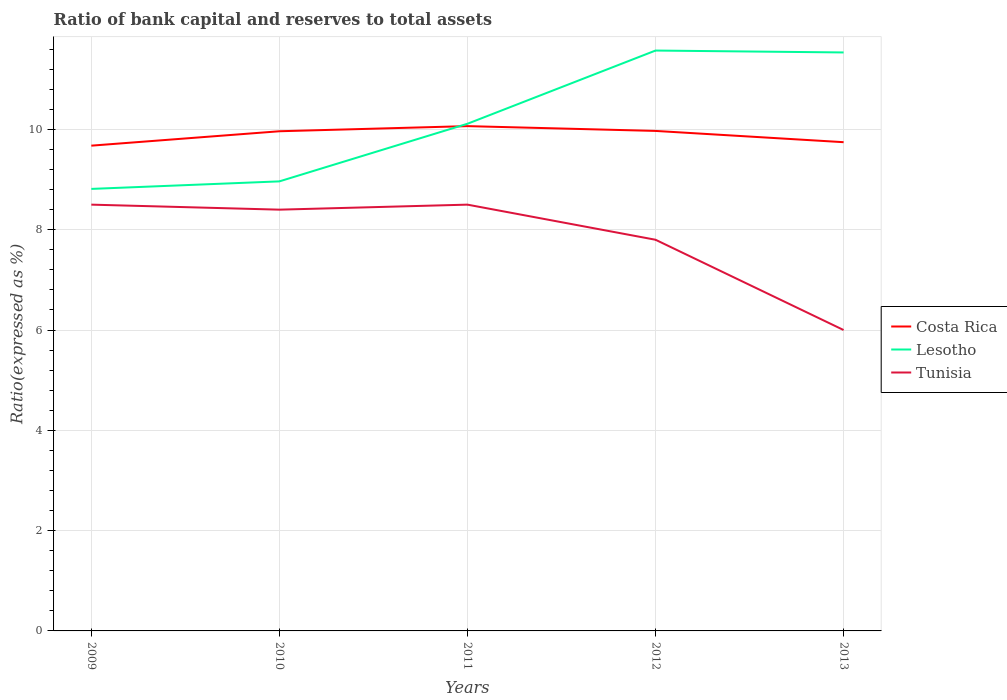How many different coloured lines are there?
Your answer should be compact. 3. Does the line corresponding to Tunisia intersect with the line corresponding to Lesotho?
Offer a terse response. No. What is the total ratio of bank capital and reserves to total assets in Costa Rica in the graph?
Give a very brief answer. -0.07. What is the difference between the highest and the second highest ratio of bank capital and reserves to total assets in Costa Rica?
Ensure brevity in your answer.  0.39. How many lines are there?
Provide a succinct answer. 3. How many years are there in the graph?
Ensure brevity in your answer.  5. Does the graph contain any zero values?
Your answer should be very brief. No. What is the title of the graph?
Offer a very short reply. Ratio of bank capital and reserves to total assets. Does "New Zealand" appear as one of the legend labels in the graph?
Your response must be concise. No. What is the label or title of the Y-axis?
Ensure brevity in your answer.  Ratio(expressed as %). What is the Ratio(expressed as %) in Costa Rica in 2009?
Your answer should be very brief. 9.68. What is the Ratio(expressed as %) in Lesotho in 2009?
Your answer should be very brief. 8.81. What is the Ratio(expressed as %) in Tunisia in 2009?
Your answer should be compact. 8.5. What is the Ratio(expressed as %) of Costa Rica in 2010?
Ensure brevity in your answer.  9.96. What is the Ratio(expressed as %) of Lesotho in 2010?
Offer a very short reply. 8.96. What is the Ratio(expressed as %) in Costa Rica in 2011?
Ensure brevity in your answer.  10.07. What is the Ratio(expressed as %) in Lesotho in 2011?
Ensure brevity in your answer.  10.11. What is the Ratio(expressed as %) of Costa Rica in 2012?
Keep it short and to the point. 9.97. What is the Ratio(expressed as %) in Lesotho in 2012?
Offer a very short reply. 11.57. What is the Ratio(expressed as %) of Costa Rica in 2013?
Offer a terse response. 9.75. What is the Ratio(expressed as %) of Lesotho in 2013?
Make the answer very short. 11.53. What is the Ratio(expressed as %) of Tunisia in 2013?
Provide a short and direct response. 6. Across all years, what is the maximum Ratio(expressed as %) of Costa Rica?
Offer a very short reply. 10.07. Across all years, what is the maximum Ratio(expressed as %) of Lesotho?
Offer a very short reply. 11.57. Across all years, what is the minimum Ratio(expressed as %) of Costa Rica?
Offer a very short reply. 9.68. Across all years, what is the minimum Ratio(expressed as %) of Lesotho?
Make the answer very short. 8.81. Across all years, what is the minimum Ratio(expressed as %) in Tunisia?
Provide a short and direct response. 6. What is the total Ratio(expressed as %) of Costa Rica in the graph?
Your answer should be compact. 49.42. What is the total Ratio(expressed as %) of Lesotho in the graph?
Keep it short and to the point. 51. What is the total Ratio(expressed as %) of Tunisia in the graph?
Make the answer very short. 39.2. What is the difference between the Ratio(expressed as %) of Costa Rica in 2009 and that in 2010?
Offer a terse response. -0.29. What is the difference between the Ratio(expressed as %) in Lesotho in 2009 and that in 2010?
Make the answer very short. -0.15. What is the difference between the Ratio(expressed as %) in Costa Rica in 2009 and that in 2011?
Offer a very short reply. -0.39. What is the difference between the Ratio(expressed as %) of Lesotho in 2009 and that in 2011?
Offer a terse response. -1.3. What is the difference between the Ratio(expressed as %) in Tunisia in 2009 and that in 2011?
Your answer should be very brief. 0. What is the difference between the Ratio(expressed as %) of Costa Rica in 2009 and that in 2012?
Your answer should be very brief. -0.29. What is the difference between the Ratio(expressed as %) of Lesotho in 2009 and that in 2012?
Offer a terse response. -2.76. What is the difference between the Ratio(expressed as %) in Costa Rica in 2009 and that in 2013?
Provide a short and direct response. -0.07. What is the difference between the Ratio(expressed as %) of Lesotho in 2009 and that in 2013?
Your answer should be very brief. -2.72. What is the difference between the Ratio(expressed as %) in Costa Rica in 2010 and that in 2011?
Your answer should be compact. -0.1. What is the difference between the Ratio(expressed as %) in Lesotho in 2010 and that in 2011?
Keep it short and to the point. -1.15. What is the difference between the Ratio(expressed as %) of Costa Rica in 2010 and that in 2012?
Your answer should be very brief. -0.01. What is the difference between the Ratio(expressed as %) of Lesotho in 2010 and that in 2012?
Make the answer very short. -2.61. What is the difference between the Ratio(expressed as %) in Tunisia in 2010 and that in 2012?
Give a very brief answer. 0.6. What is the difference between the Ratio(expressed as %) of Costa Rica in 2010 and that in 2013?
Give a very brief answer. 0.22. What is the difference between the Ratio(expressed as %) in Lesotho in 2010 and that in 2013?
Offer a terse response. -2.57. What is the difference between the Ratio(expressed as %) in Costa Rica in 2011 and that in 2012?
Offer a very short reply. 0.1. What is the difference between the Ratio(expressed as %) of Lesotho in 2011 and that in 2012?
Provide a short and direct response. -1.46. What is the difference between the Ratio(expressed as %) in Costa Rica in 2011 and that in 2013?
Make the answer very short. 0.32. What is the difference between the Ratio(expressed as %) of Lesotho in 2011 and that in 2013?
Make the answer very short. -1.42. What is the difference between the Ratio(expressed as %) in Tunisia in 2011 and that in 2013?
Your response must be concise. 2.5. What is the difference between the Ratio(expressed as %) in Costa Rica in 2012 and that in 2013?
Your response must be concise. 0.22. What is the difference between the Ratio(expressed as %) in Lesotho in 2012 and that in 2013?
Provide a short and direct response. 0.04. What is the difference between the Ratio(expressed as %) in Tunisia in 2012 and that in 2013?
Make the answer very short. 1.8. What is the difference between the Ratio(expressed as %) in Costa Rica in 2009 and the Ratio(expressed as %) in Lesotho in 2010?
Offer a terse response. 0.71. What is the difference between the Ratio(expressed as %) of Costa Rica in 2009 and the Ratio(expressed as %) of Tunisia in 2010?
Your response must be concise. 1.28. What is the difference between the Ratio(expressed as %) of Lesotho in 2009 and the Ratio(expressed as %) of Tunisia in 2010?
Make the answer very short. 0.41. What is the difference between the Ratio(expressed as %) in Costa Rica in 2009 and the Ratio(expressed as %) in Lesotho in 2011?
Your answer should be very brief. -0.44. What is the difference between the Ratio(expressed as %) in Costa Rica in 2009 and the Ratio(expressed as %) in Tunisia in 2011?
Your response must be concise. 1.18. What is the difference between the Ratio(expressed as %) in Lesotho in 2009 and the Ratio(expressed as %) in Tunisia in 2011?
Provide a short and direct response. 0.31. What is the difference between the Ratio(expressed as %) in Costa Rica in 2009 and the Ratio(expressed as %) in Lesotho in 2012?
Make the answer very short. -1.9. What is the difference between the Ratio(expressed as %) in Costa Rica in 2009 and the Ratio(expressed as %) in Tunisia in 2012?
Offer a very short reply. 1.88. What is the difference between the Ratio(expressed as %) in Lesotho in 2009 and the Ratio(expressed as %) in Tunisia in 2012?
Ensure brevity in your answer.  1.01. What is the difference between the Ratio(expressed as %) of Costa Rica in 2009 and the Ratio(expressed as %) of Lesotho in 2013?
Keep it short and to the point. -1.86. What is the difference between the Ratio(expressed as %) of Costa Rica in 2009 and the Ratio(expressed as %) of Tunisia in 2013?
Provide a succinct answer. 3.68. What is the difference between the Ratio(expressed as %) of Lesotho in 2009 and the Ratio(expressed as %) of Tunisia in 2013?
Offer a very short reply. 2.81. What is the difference between the Ratio(expressed as %) in Costa Rica in 2010 and the Ratio(expressed as %) in Lesotho in 2011?
Your response must be concise. -0.15. What is the difference between the Ratio(expressed as %) in Costa Rica in 2010 and the Ratio(expressed as %) in Tunisia in 2011?
Give a very brief answer. 1.46. What is the difference between the Ratio(expressed as %) in Lesotho in 2010 and the Ratio(expressed as %) in Tunisia in 2011?
Your answer should be compact. 0.46. What is the difference between the Ratio(expressed as %) of Costa Rica in 2010 and the Ratio(expressed as %) of Lesotho in 2012?
Ensure brevity in your answer.  -1.61. What is the difference between the Ratio(expressed as %) in Costa Rica in 2010 and the Ratio(expressed as %) in Tunisia in 2012?
Keep it short and to the point. 2.16. What is the difference between the Ratio(expressed as %) of Lesotho in 2010 and the Ratio(expressed as %) of Tunisia in 2012?
Keep it short and to the point. 1.16. What is the difference between the Ratio(expressed as %) in Costa Rica in 2010 and the Ratio(expressed as %) in Lesotho in 2013?
Ensure brevity in your answer.  -1.57. What is the difference between the Ratio(expressed as %) of Costa Rica in 2010 and the Ratio(expressed as %) of Tunisia in 2013?
Provide a succinct answer. 3.96. What is the difference between the Ratio(expressed as %) in Lesotho in 2010 and the Ratio(expressed as %) in Tunisia in 2013?
Keep it short and to the point. 2.96. What is the difference between the Ratio(expressed as %) in Costa Rica in 2011 and the Ratio(expressed as %) in Lesotho in 2012?
Your answer should be very brief. -1.51. What is the difference between the Ratio(expressed as %) of Costa Rica in 2011 and the Ratio(expressed as %) of Tunisia in 2012?
Offer a very short reply. 2.27. What is the difference between the Ratio(expressed as %) in Lesotho in 2011 and the Ratio(expressed as %) in Tunisia in 2012?
Offer a very short reply. 2.31. What is the difference between the Ratio(expressed as %) in Costa Rica in 2011 and the Ratio(expressed as %) in Lesotho in 2013?
Ensure brevity in your answer.  -1.47. What is the difference between the Ratio(expressed as %) of Costa Rica in 2011 and the Ratio(expressed as %) of Tunisia in 2013?
Make the answer very short. 4.07. What is the difference between the Ratio(expressed as %) of Lesotho in 2011 and the Ratio(expressed as %) of Tunisia in 2013?
Provide a short and direct response. 4.11. What is the difference between the Ratio(expressed as %) of Costa Rica in 2012 and the Ratio(expressed as %) of Lesotho in 2013?
Your answer should be compact. -1.56. What is the difference between the Ratio(expressed as %) in Costa Rica in 2012 and the Ratio(expressed as %) in Tunisia in 2013?
Your answer should be compact. 3.97. What is the difference between the Ratio(expressed as %) of Lesotho in 2012 and the Ratio(expressed as %) of Tunisia in 2013?
Offer a very short reply. 5.57. What is the average Ratio(expressed as %) of Costa Rica per year?
Offer a very short reply. 9.88. What is the average Ratio(expressed as %) in Lesotho per year?
Offer a very short reply. 10.2. What is the average Ratio(expressed as %) in Tunisia per year?
Offer a terse response. 7.84. In the year 2009, what is the difference between the Ratio(expressed as %) of Costa Rica and Ratio(expressed as %) of Lesotho?
Your answer should be compact. 0.86. In the year 2009, what is the difference between the Ratio(expressed as %) of Costa Rica and Ratio(expressed as %) of Tunisia?
Your answer should be compact. 1.18. In the year 2009, what is the difference between the Ratio(expressed as %) of Lesotho and Ratio(expressed as %) of Tunisia?
Ensure brevity in your answer.  0.31. In the year 2010, what is the difference between the Ratio(expressed as %) of Costa Rica and Ratio(expressed as %) of Tunisia?
Offer a terse response. 1.56. In the year 2010, what is the difference between the Ratio(expressed as %) of Lesotho and Ratio(expressed as %) of Tunisia?
Your answer should be compact. 0.56. In the year 2011, what is the difference between the Ratio(expressed as %) in Costa Rica and Ratio(expressed as %) in Lesotho?
Offer a terse response. -0.05. In the year 2011, what is the difference between the Ratio(expressed as %) of Costa Rica and Ratio(expressed as %) of Tunisia?
Your answer should be very brief. 1.57. In the year 2011, what is the difference between the Ratio(expressed as %) of Lesotho and Ratio(expressed as %) of Tunisia?
Provide a succinct answer. 1.61. In the year 2012, what is the difference between the Ratio(expressed as %) in Costa Rica and Ratio(expressed as %) in Lesotho?
Your answer should be compact. -1.6. In the year 2012, what is the difference between the Ratio(expressed as %) of Costa Rica and Ratio(expressed as %) of Tunisia?
Provide a succinct answer. 2.17. In the year 2012, what is the difference between the Ratio(expressed as %) in Lesotho and Ratio(expressed as %) in Tunisia?
Make the answer very short. 3.77. In the year 2013, what is the difference between the Ratio(expressed as %) of Costa Rica and Ratio(expressed as %) of Lesotho?
Give a very brief answer. -1.79. In the year 2013, what is the difference between the Ratio(expressed as %) of Costa Rica and Ratio(expressed as %) of Tunisia?
Give a very brief answer. 3.75. In the year 2013, what is the difference between the Ratio(expressed as %) of Lesotho and Ratio(expressed as %) of Tunisia?
Offer a very short reply. 5.53. What is the ratio of the Ratio(expressed as %) of Costa Rica in 2009 to that in 2010?
Provide a succinct answer. 0.97. What is the ratio of the Ratio(expressed as %) of Lesotho in 2009 to that in 2010?
Keep it short and to the point. 0.98. What is the ratio of the Ratio(expressed as %) in Tunisia in 2009 to that in 2010?
Provide a succinct answer. 1.01. What is the ratio of the Ratio(expressed as %) of Costa Rica in 2009 to that in 2011?
Give a very brief answer. 0.96. What is the ratio of the Ratio(expressed as %) of Lesotho in 2009 to that in 2011?
Give a very brief answer. 0.87. What is the ratio of the Ratio(expressed as %) of Tunisia in 2009 to that in 2011?
Provide a succinct answer. 1. What is the ratio of the Ratio(expressed as %) in Costa Rica in 2009 to that in 2012?
Your response must be concise. 0.97. What is the ratio of the Ratio(expressed as %) in Lesotho in 2009 to that in 2012?
Your answer should be very brief. 0.76. What is the ratio of the Ratio(expressed as %) in Tunisia in 2009 to that in 2012?
Make the answer very short. 1.09. What is the ratio of the Ratio(expressed as %) in Costa Rica in 2009 to that in 2013?
Give a very brief answer. 0.99. What is the ratio of the Ratio(expressed as %) in Lesotho in 2009 to that in 2013?
Offer a very short reply. 0.76. What is the ratio of the Ratio(expressed as %) in Tunisia in 2009 to that in 2013?
Make the answer very short. 1.42. What is the ratio of the Ratio(expressed as %) of Lesotho in 2010 to that in 2011?
Make the answer very short. 0.89. What is the ratio of the Ratio(expressed as %) of Costa Rica in 2010 to that in 2012?
Offer a terse response. 1. What is the ratio of the Ratio(expressed as %) of Lesotho in 2010 to that in 2012?
Ensure brevity in your answer.  0.77. What is the ratio of the Ratio(expressed as %) in Costa Rica in 2010 to that in 2013?
Give a very brief answer. 1.02. What is the ratio of the Ratio(expressed as %) in Lesotho in 2010 to that in 2013?
Offer a terse response. 0.78. What is the ratio of the Ratio(expressed as %) of Costa Rica in 2011 to that in 2012?
Your answer should be very brief. 1.01. What is the ratio of the Ratio(expressed as %) in Lesotho in 2011 to that in 2012?
Provide a succinct answer. 0.87. What is the ratio of the Ratio(expressed as %) of Tunisia in 2011 to that in 2012?
Your answer should be compact. 1.09. What is the ratio of the Ratio(expressed as %) of Costa Rica in 2011 to that in 2013?
Provide a succinct answer. 1.03. What is the ratio of the Ratio(expressed as %) of Lesotho in 2011 to that in 2013?
Your answer should be very brief. 0.88. What is the ratio of the Ratio(expressed as %) in Tunisia in 2011 to that in 2013?
Ensure brevity in your answer.  1.42. What is the ratio of the Ratio(expressed as %) of Costa Rica in 2012 to that in 2013?
Offer a very short reply. 1.02. What is the ratio of the Ratio(expressed as %) in Lesotho in 2012 to that in 2013?
Offer a very short reply. 1. What is the difference between the highest and the second highest Ratio(expressed as %) in Costa Rica?
Offer a very short reply. 0.1. What is the difference between the highest and the second highest Ratio(expressed as %) of Lesotho?
Your answer should be very brief. 0.04. What is the difference between the highest and the second highest Ratio(expressed as %) of Tunisia?
Offer a very short reply. 0. What is the difference between the highest and the lowest Ratio(expressed as %) of Costa Rica?
Your answer should be compact. 0.39. What is the difference between the highest and the lowest Ratio(expressed as %) of Lesotho?
Your answer should be very brief. 2.76. What is the difference between the highest and the lowest Ratio(expressed as %) of Tunisia?
Your answer should be very brief. 2.5. 